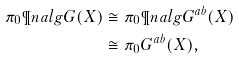Convert formula to latex. <formula><loc_0><loc_0><loc_500><loc_500>\pi _ { 0 } \P n a l g G ( X ) & \cong \pi _ { 0 } \P n a l g G ^ { a b } ( X ) \\ & \cong \pi _ { 0 } G ^ { a b } ( X ) ,</formula> 